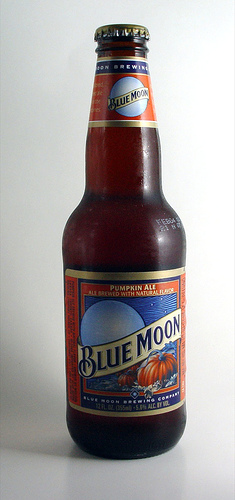<image>
Is the label above the bottle? No. The label is not positioned above the bottle. The vertical arrangement shows a different relationship. 